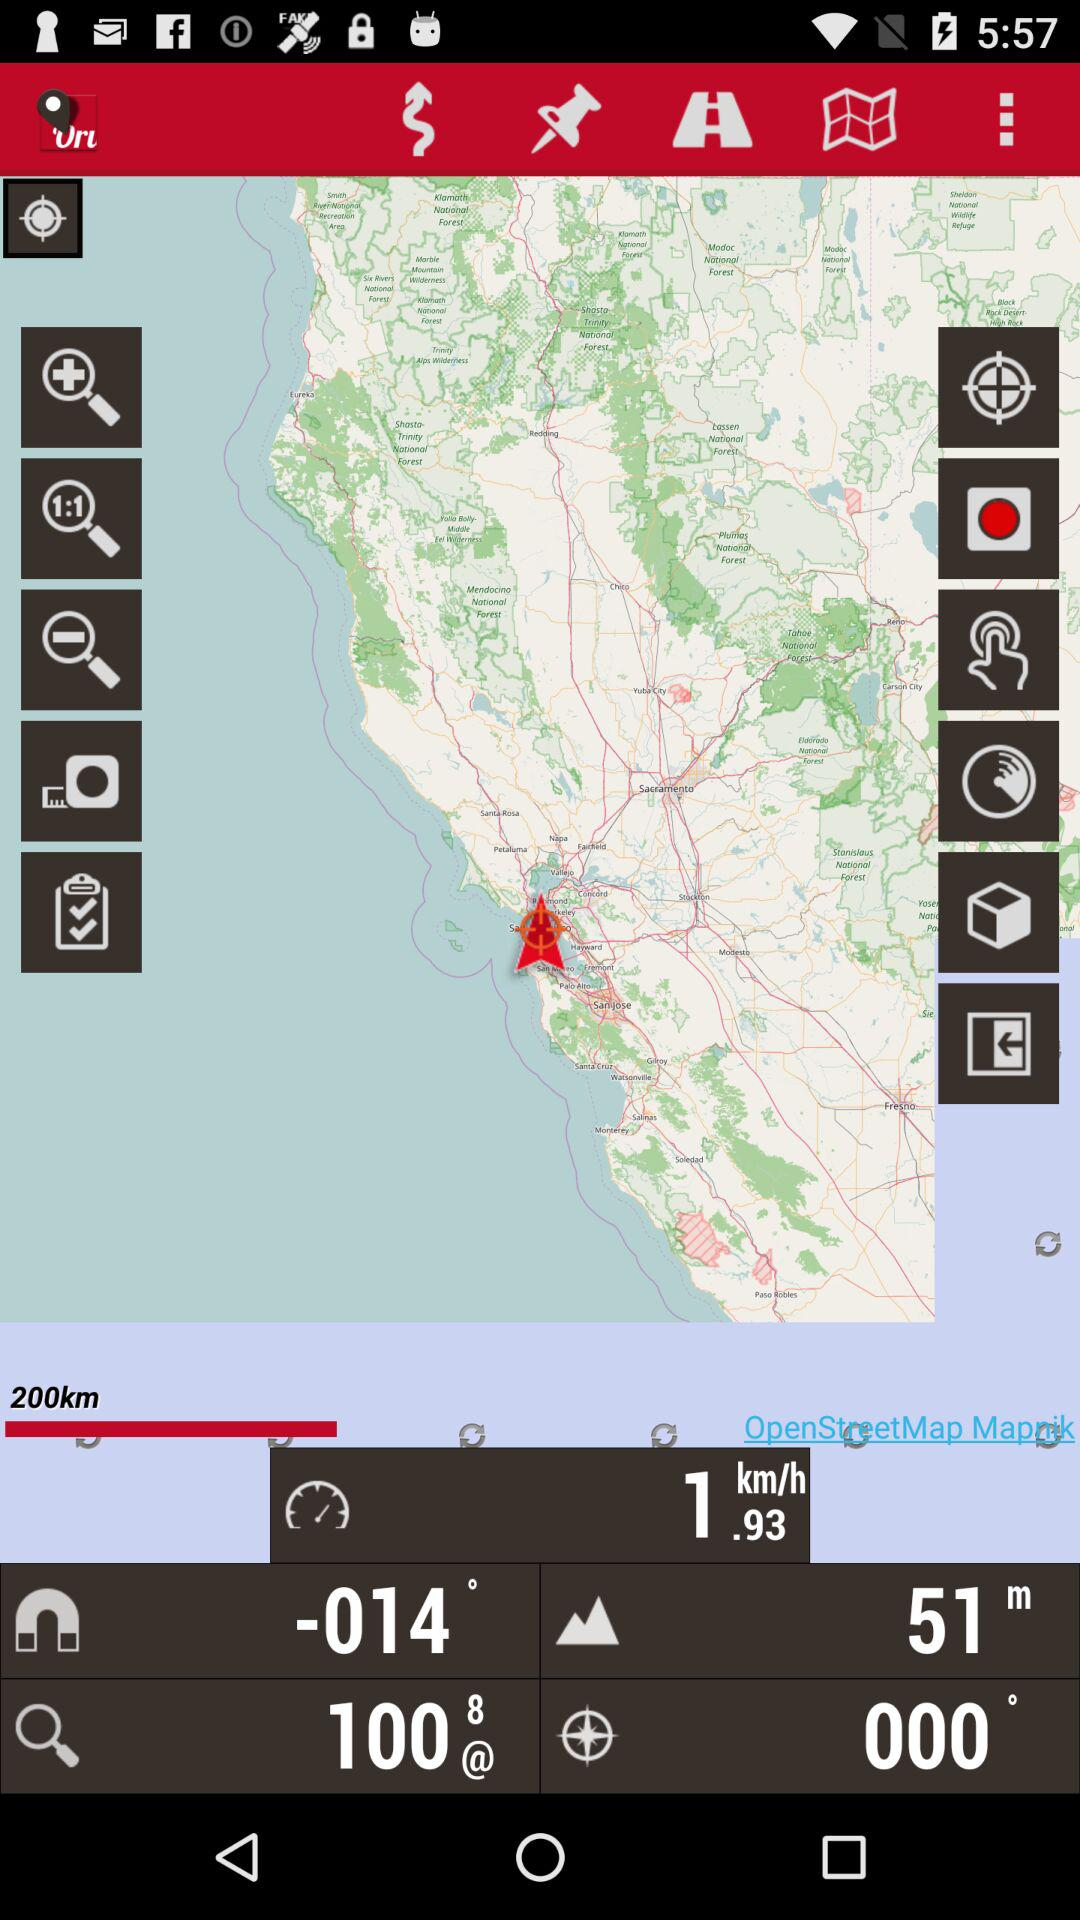What is the range? The range is 200 kilometers. 